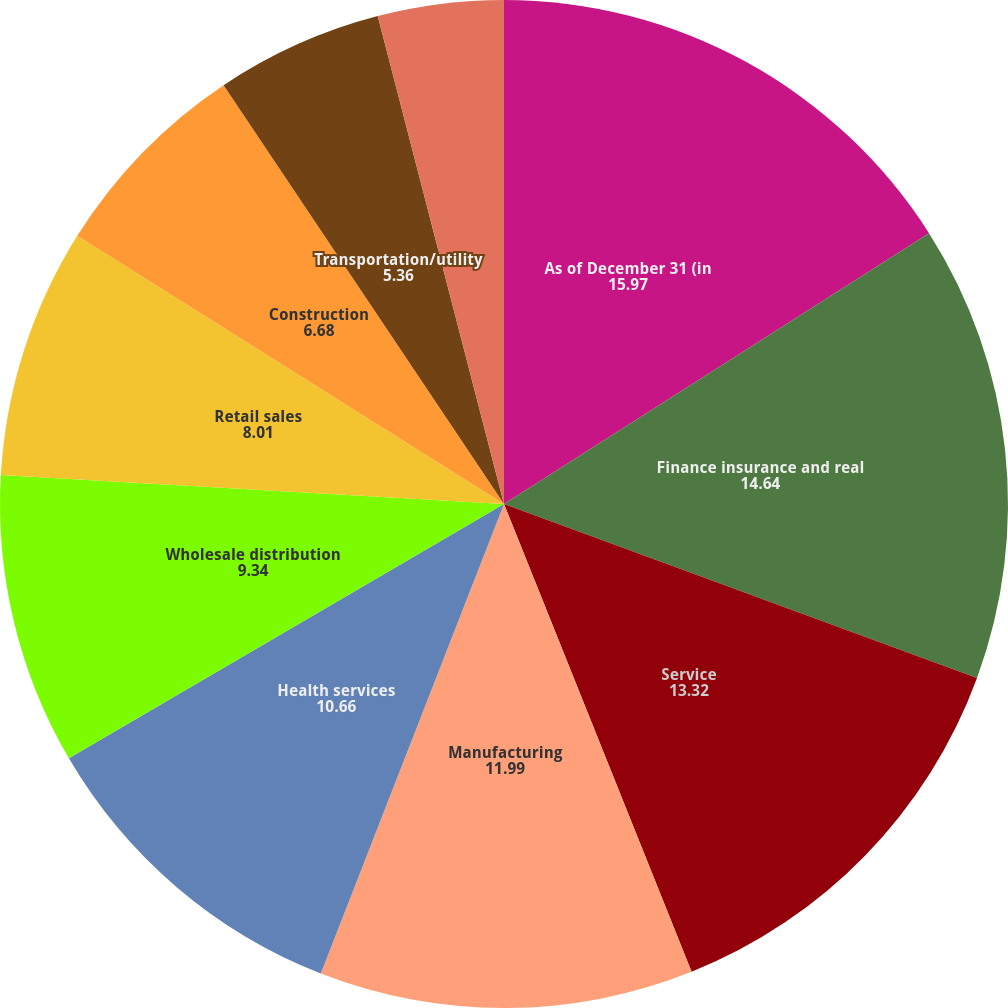<chart> <loc_0><loc_0><loc_500><loc_500><pie_chart><fcel>As of December 31 (in<fcel>Finance insurance and real<fcel>Service<fcel>Manufacturing<fcel>Health services<fcel>Wholesale distribution<fcel>Retail sales<fcel>Construction<fcel>Transportation/utility<fcel>Arts/entertainment/recreation<nl><fcel>15.97%<fcel>14.64%<fcel>13.32%<fcel>11.99%<fcel>10.66%<fcel>9.34%<fcel>8.01%<fcel>6.68%<fcel>5.36%<fcel>4.03%<nl></chart> 